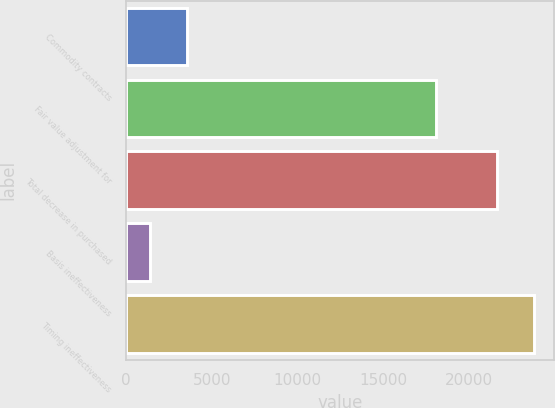Convert chart. <chart><loc_0><loc_0><loc_500><loc_500><bar_chart><fcel>Commodity contracts<fcel>Fair value adjustment for<fcel>Total decrease in purchased<fcel>Basis ineffectiveness<fcel>Timing ineffectiveness<nl><fcel>3549.5<fcel>18079<fcel>21595<fcel>1390<fcel>23754.5<nl></chart> 